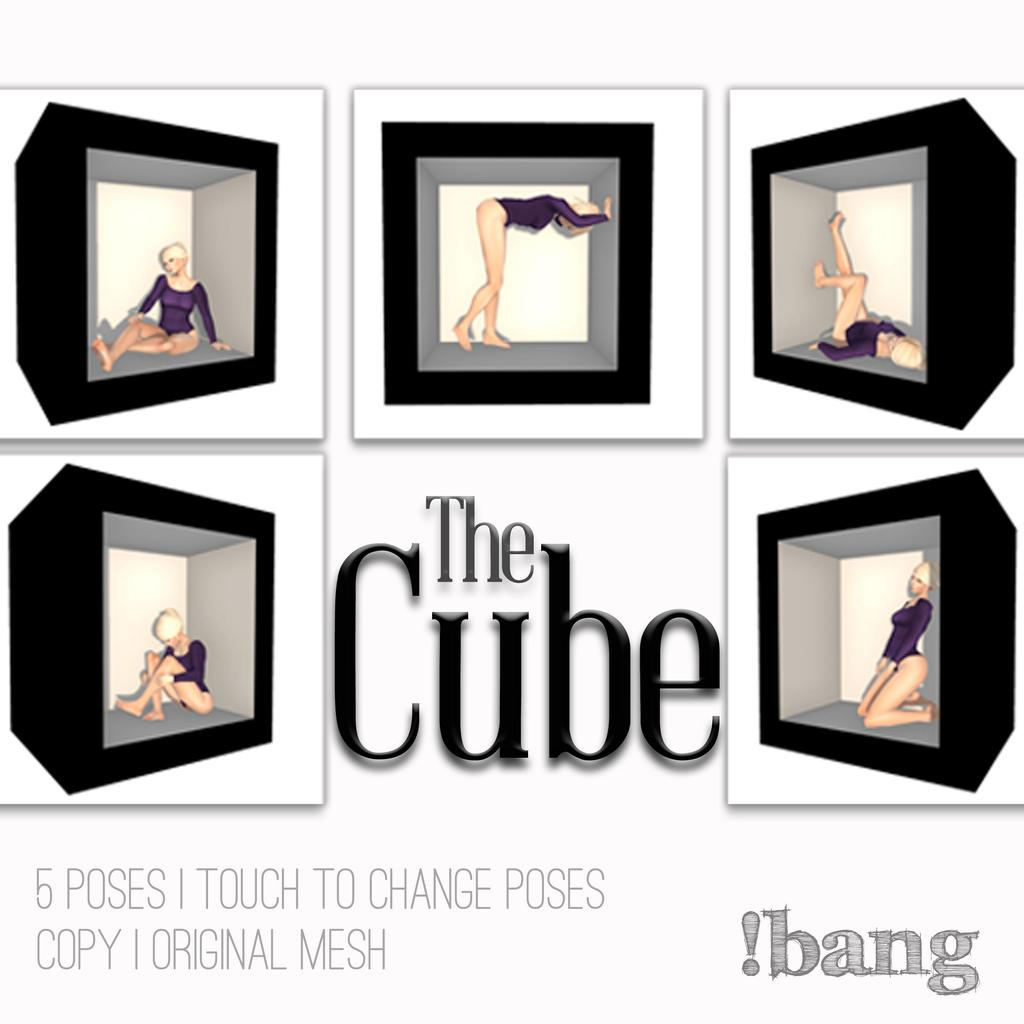<image>
Create a compact narrative representing the image presented. Five black cubes containing a woman in different positions is animated with the words The Cube. 